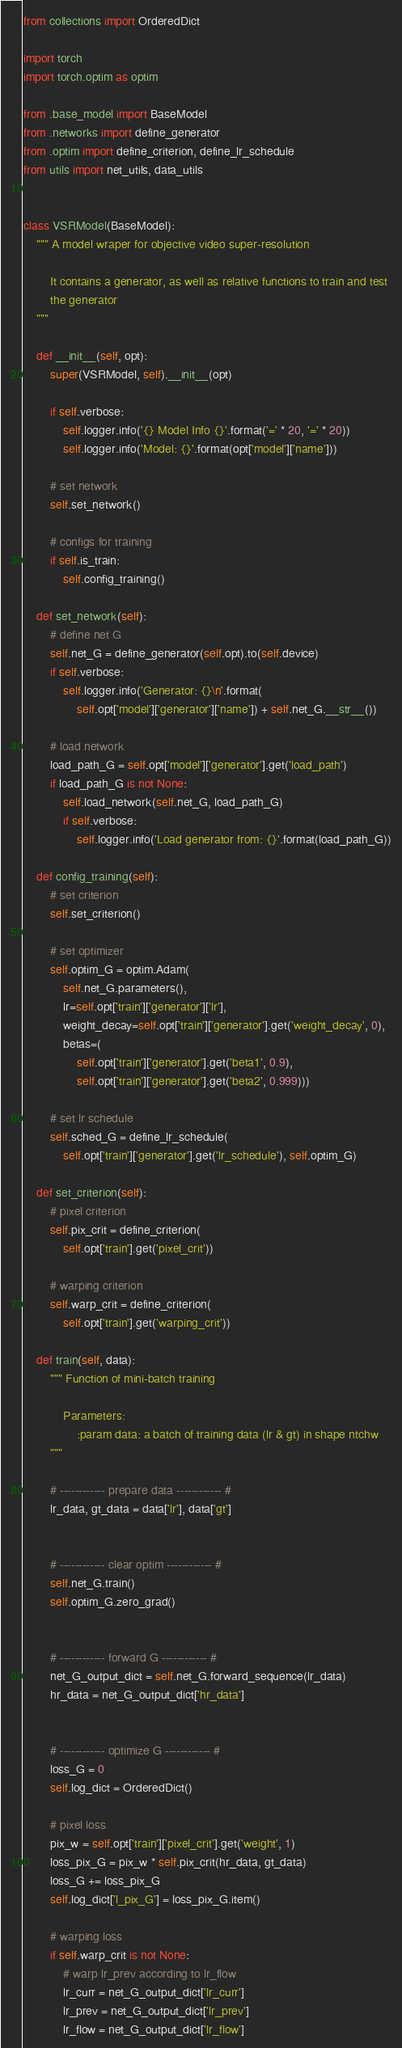Convert code to text. <code><loc_0><loc_0><loc_500><loc_500><_Python_>from collections import OrderedDict

import torch
import torch.optim as optim

from .base_model import BaseModel
from .networks import define_generator
from .optim import define_criterion, define_lr_schedule
from utils import net_utils, data_utils


class VSRModel(BaseModel):
    """ A model wraper for objective video super-resolution

        It contains a generator, as well as relative functions to train and test
        the generator
    """

    def __init__(self, opt):
        super(VSRModel, self).__init__(opt)

        if self.verbose:
            self.logger.info('{} Model Info {}'.format('=' * 20, '=' * 20))
            self.logger.info('Model: {}'.format(opt['model']['name']))

        # set network
        self.set_network()

        # configs for training
        if self.is_train:
            self.config_training()

    def set_network(self):
        # define net G
        self.net_G = define_generator(self.opt).to(self.device)
        if self.verbose:
            self.logger.info('Generator: {}\n'.format(
                self.opt['model']['generator']['name']) + self.net_G.__str__())

        # load network
        load_path_G = self.opt['model']['generator'].get('load_path')
        if load_path_G is not None:
            self.load_network(self.net_G, load_path_G)
            if self.verbose:
                self.logger.info('Load generator from: {}'.format(load_path_G))

    def config_training(self):
        # set criterion
        self.set_criterion()

        # set optimizer
        self.optim_G = optim.Adam(
            self.net_G.parameters(),
            lr=self.opt['train']['generator']['lr'],
            weight_decay=self.opt['train']['generator'].get('weight_decay', 0),
            betas=(
                self.opt['train']['generator'].get('beta1', 0.9),
                self.opt['train']['generator'].get('beta2', 0.999)))

        # set lr schedule
        self.sched_G = define_lr_schedule(
            self.opt['train']['generator'].get('lr_schedule'), self.optim_G)

    def set_criterion(self):
        # pixel criterion
        self.pix_crit = define_criterion(
            self.opt['train'].get('pixel_crit'))

        # warping criterion
        self.warp_crit = define_criterion(
            self.opt['train'].get('warping_crit'))

    def train(self, data):
        """ Function of mini-batch training

            Parameters:
                :param data: a batch of training data (lr & gt) in shape ntchw
        """

        # ------------ prepare data ------------ #
        lr_data, gt_data = data['lr'], data['gt']


        # ------------ clear optim ------------ #
        self.net_G.train()
        self.optim_G.zero_grad()


        # ------------ forward G ------------ #
        net_G_output_dict = self.net_G.forward_sequence(lr_data)
        hr_data = net_G_output_dict['hr_data']


        # ------------ optimize G ------------ #
        loss_G = 0
        self.log_dict = OrderedDict()

        # pixel loss
        pix_w = self.opt['train']['pixel_crit'].get('weight', 1)
        loss_pix_G = pix_w * self.pix_crit(hr_data, gt_data)
        loss_G += loss_pix_G
        self.log_dict['l_pix_G'] = loss_pix_G.item()

        # warping loss
        if self.warp_crit is not None:
            # warp lr_prev according to lr_flow
            lr_curr = net_G_output_dict['lr_curr']
            lr_prev = net_G_output_dict['lr_prev']
            lr_flow = net_G_output_dict['lr_flow']</code> 